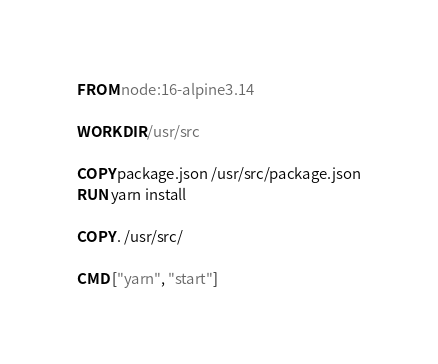Convert code to text. <code><loc_0><loc_0><loc_500><loc_500><_Dockerfile_>FROM node:16-alpine3.14

WORKDIR /usr/src

COPY package.json /usr/src/package.json
RUN yarn install

COPY . /usr/src/

CMD ["yarn", "start"]</code> 